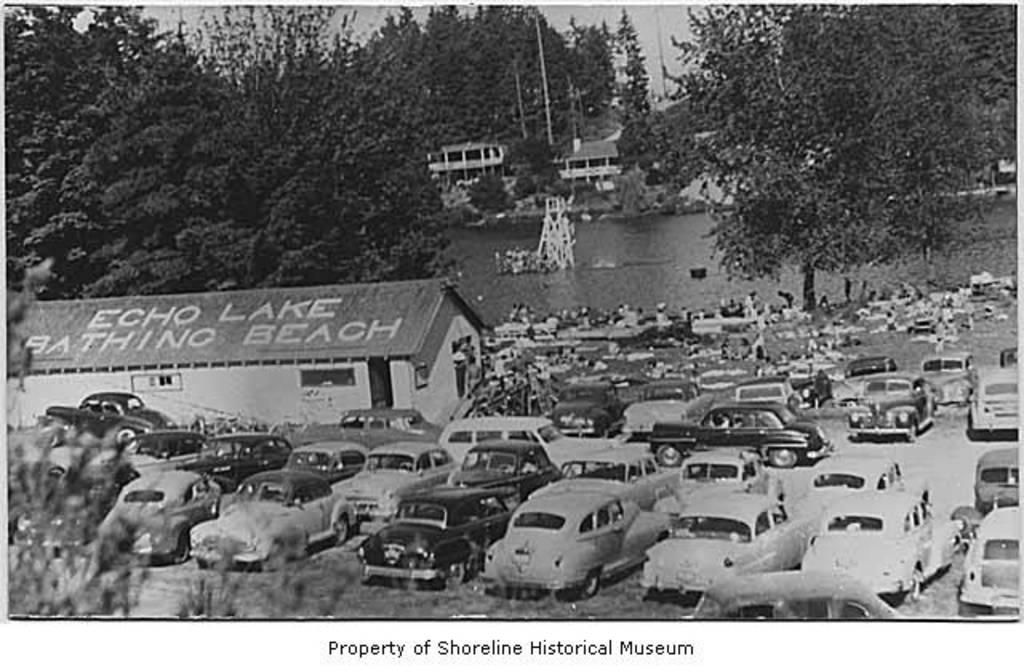What types of objects can be seen in the image? There are vehicles, a house, water, trees, and buildings in the image. Can you describe the setting of the image? The image features a combination of natural elements, such as water and trees, and man-made structures, like buildings and a house. What is present at the bottom of the image? There is text at the bottom of the image. Can you see a father figure in the image? There is no father figure present in the image. 